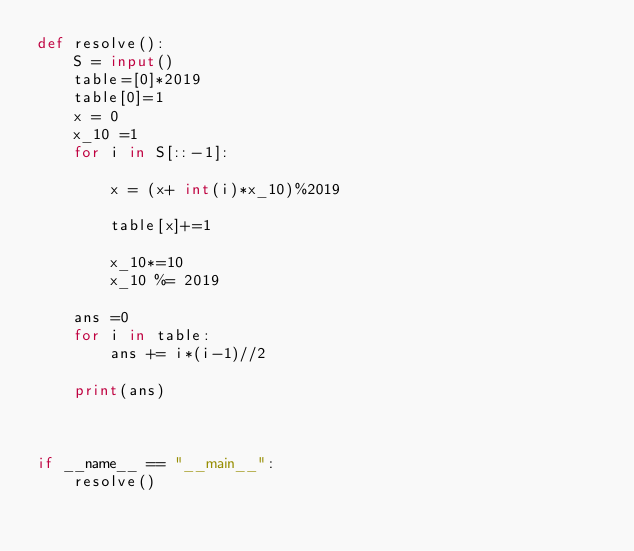<code> <loc_0><loc_0><loc_500><loc_500><_Python_>def resolve():
    S = input()
    table=[0]*2019
    table[0]=1
    x = 0
    x_10 =1
    for i in S[::-1]:

        x = (x+ int(i)*x_10)%2019

        table[x]+=1

        x_10*=10
        x_10 %= 2019

    ans =0
    for i in table:
        ans += i*(i-1)//2
    
    print(ans)



if __name__ == "__main__":
    resolve()</code> 